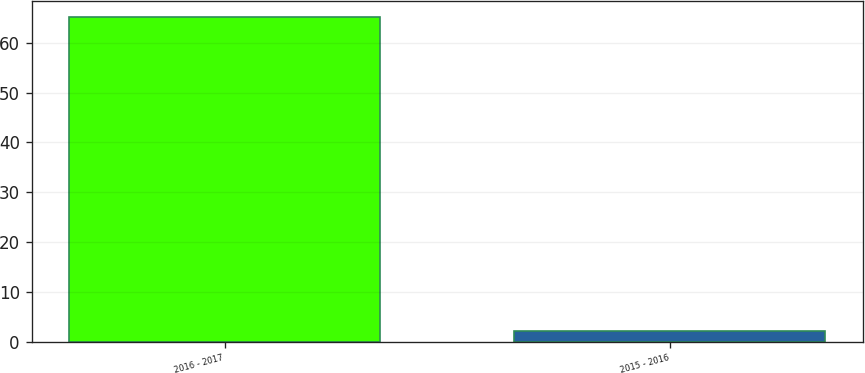Convert chart. <chart><loc_0><loc_0><loc_500><loc_500><bar_chart><fcel>2016 - 2017<fcel>2015 - 2016<nl><fcel>65.2<fcel>2.2<nl></chart> 